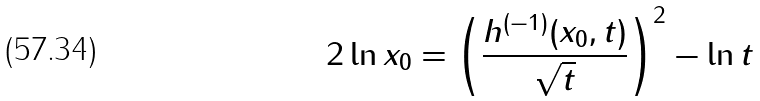<formula> <loc_0><loc_0><loc_500><loc_500>2 \ln x _ { 0 } = \left ( \frac { h ^ { ( - 1 ) } ( x _ { 0 } , t ) } { \sqrt { t } } \right ) ^ { 2 } - \ln t</formula> 